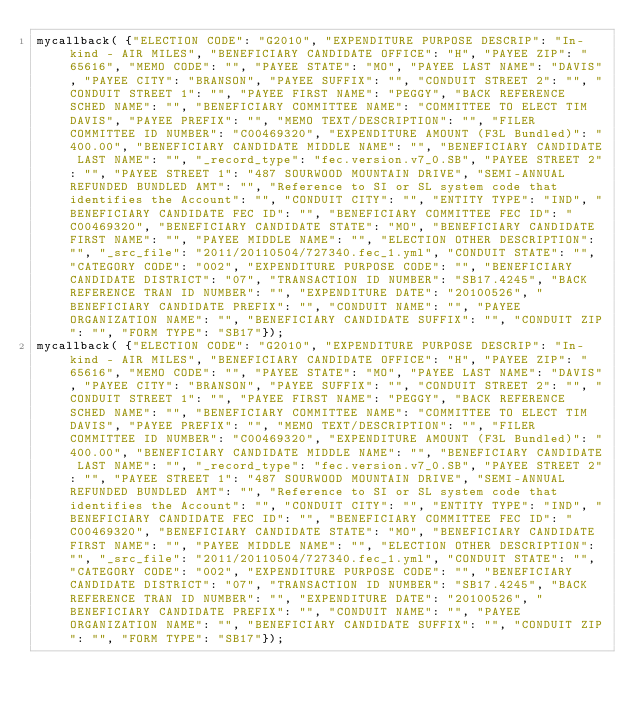Convert code to text. <code><loc_0><loc_0><loc_500><loc_500><_JavaScript_>mycallback( {"ELECTION CODE": "G2010", "EXPENDITURE PURPOSE DESCRIP": "In-kind - AIR MILES", "BENEFICIARY CANDIDATE OFFICE": "H", "PAYEE ZIP": "65616", "MEMO CODE": "", "PAYEE STATE": "MO", "PAYEE LAST NAME": "DAVIS", "PAYEE CITY": "BRANSON", "PAYEE SUFFIX": "", "CONDUIT STREET 2": "", "CONDUIT STREET 1": "", "PAYEE FIRST NAME": "PEGGY", "BACK REFERENCE SCHED NAME": "", "BENEFICIARY COMMITTEE NAME": "COMMITTEE TO ELECT TIM DAVIS", "PAYEE PREFIX": "", "MEMO TEXT/DESCRIPTION": "", "FILER COMMITTEE ID NUMBER": "C00469320", "EXPENDITURE AMOUNT (F3L Bundled)": "400.00", "BENEFICIARY CANDIDATE MIDDLE NAME": "", "BENEFICIARY CANDIDATE LAST NAME": "", "_record_type": "fec.version.v7_0.SB", "PAYEE STREET 2": "", "PAYEE STREET 1": "487 SOURWOOD MOUNTAIN DRIVE", "SEMI-ANNUAL REFUNDED BUNDLED AMT": "", "Reference to SI or SL system code that identifies the Account": "", "CONDUIT CITY": "", "ENTITY TYPE": "IND", "BENEFICIARY CANDIDATE FEC ID": "", "BENEFICIARY COMMITTEE FEC ID": "C00469320", "BENEFICIARY CANDIDATE STATE": "MO", "BENEFICIARY CANDIDATE FIRST NAME": "", "PAYEE MIDDLE NAME": "", "ELECTION OTHER DESCRIPTION": "", "_src_file": "2011/20110504/727340.fec_1.yml", "CONDUIT STATE": "", "CATEGORY CODE": "002", "EXPENDITURE PURPOSE CODE": "", "BENEFICIARY CANDIDATE DISTRICT": "07", "TRANSACTION ID NUMBER": "SB17.4245", "BACK REFERENCE TRAN ID NUMBER": "", "EXPENDITURE DATE": "20100526", "BENEFICIARY CANDIDATE PREFIX": "", "CONDUIT NAME": "", "PAYEE ORGANIZATION NAME": "", "BENEFICIARY CANDIDATE SUFFIX": "", "CONDUIT ZIP": "", "FORM TYPE": "SB17"});
mycallback( {"ELECTION CODE": "G2010", "EXPENDITURE PURPOSE DESCRIP": "In-kind - AIR MILES", "BENEFICIARY CANDIDATE OFFICE": "H", "PAYEE ZIP": "65616", "MEMO CODE": "", "PAYEE STATE": "MO", "PAYEE LAST NAME": "DAVIS", "PAYEE CITY": "BRANSON", "PAYEE SUFFIX": "", "CONDUIT STREET 2": "", "CONDUIT STREET 1": "", "PAYEE FIRST NAME": "PEGGY", "BACK REFERENCE SCHED NAME": "", "BENEFICIARY COMMITTEE NAME": "COMMITTEE TO ELECT TIM DAVIS", "PAYEE PREFIX": "", "MEMO TEXT/DESCRIPTION": "", "FILER COMMITTEE ID NUMBER": "C00469320", "EXPENDITURE AMOUNT (F3L Bundled)": "400.00", "BENEFICIARY CANDIDATE MIDDLE NAME": "", "BENEFICIARY CANDIDATE LAST NAME": "", "_record_type": "fec.version.v7_0.SB", "PAYEE STREET 2": "", "PAYEE STREET 1": "487 SOURWOOD MOUNTAIN DRIVE", "SEMI-ANNUAL REFUNDED BUNDLED AMT": "", "Reference to SI or SL system code that identifies the Account": "", "CONDUIT CITY": "", "ENTITY TYPE": "IND", "BENEFICIARY CANDIDATE FEC ID": "", "BENEFICIARY COMMITTEE FEC ID": "C00469320", "BENEFICIARY CANDIDATE STATE": "MO", "BENEFICIARY CANDIDATE FIRST NAME": "", "PAYEE MIDDLE NAME": "", "ELECTION OTHER DESCRIPTION": "", "_src_file": "2011/20110504/727340.fec_1.yml", "CONDUIT STATE": "", "CATEGORY CODE": "002", "EXPENDITURE PURPOSE CODE": "", "BENEFICIARY CANDIDATE DISTRICT": "07", "TRANSACTION ID NUMBER": "SB17.4245", "BACK REFERENCE TRAN ID NUMBER": "", "EXPENDITURE DATE": "20100526", "BENEFICIARY CANDIDATE PREFIX": "", "CONDUIT NAME": "", "PAYEE ORGANIZATION NAME": "", "BENEFICIARY CANDIDATE SUFFIX": "", "CONDUIT ZIP": "", "FORM TYPE": "SB17"});
</code> 